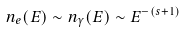Convert formula to latex. <formula><loc_0><loc_0><loc_500><loc_500>n _ { e } ( E ) \sim n _ { \gamma } ( E ) \sim E ^ { - ( s + 1 ) }</formula> 